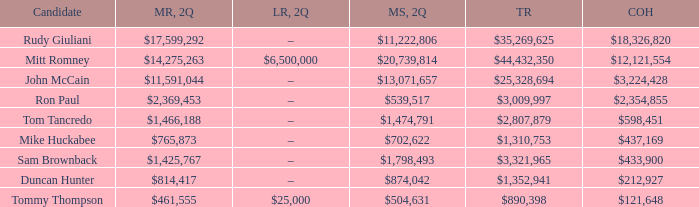Tell me the money raised when 2Q has total receipts of $890,398 $461,555. 